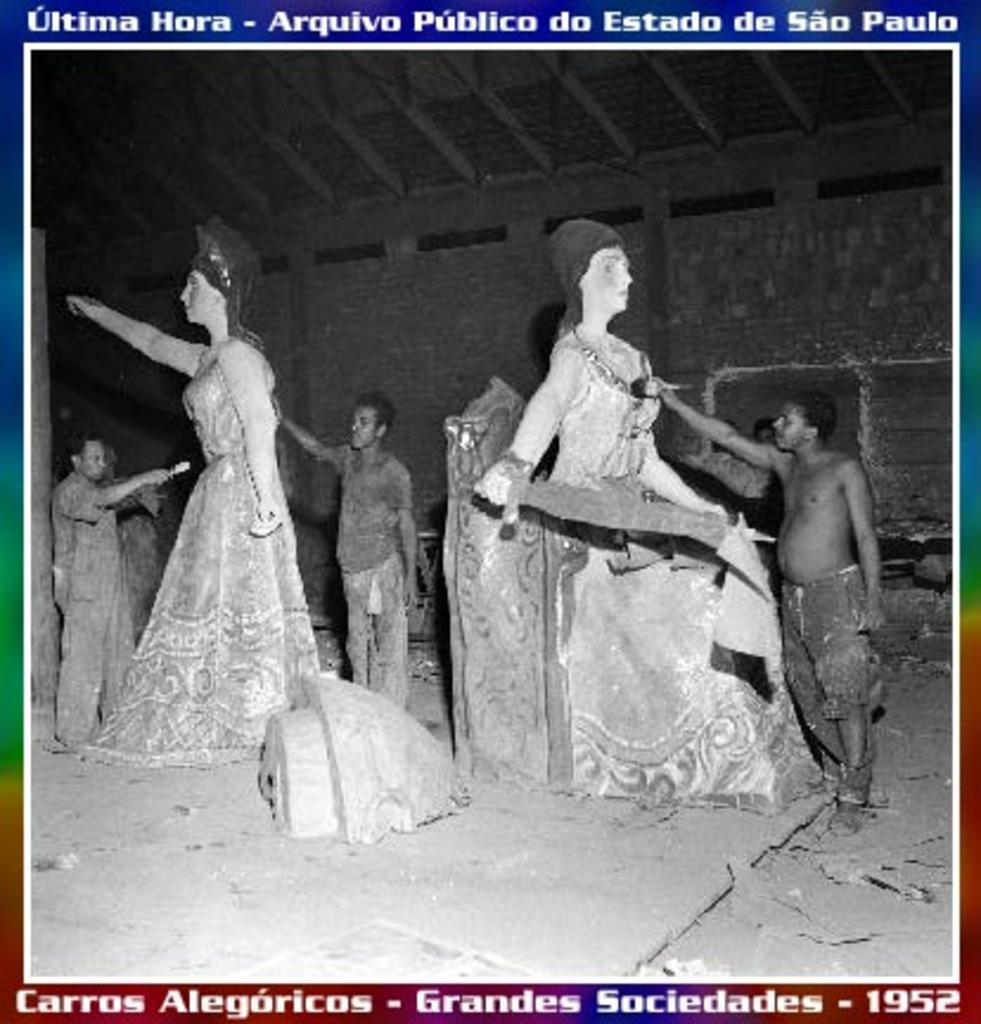<image>
Relay a brief, clear account of the picture shown. 1952 stamp showing black men painting white female statues 